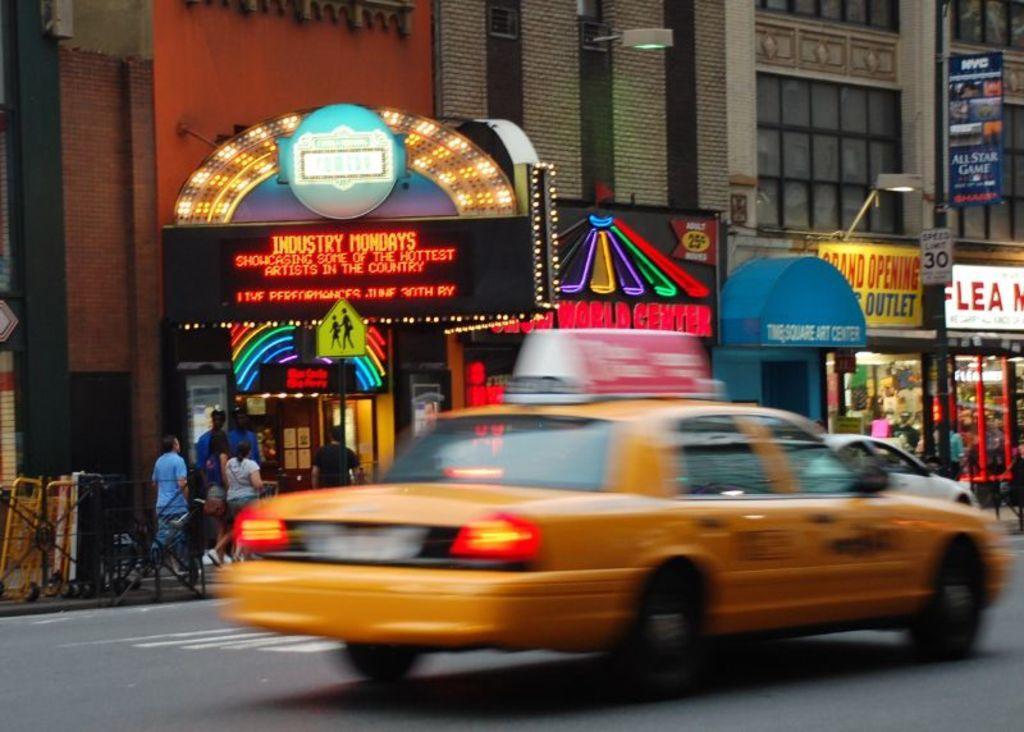How would you summarize this image in a sentence or two? In this picture we can see there are vehicles on the road. Behind the vehicles, there are boards, barricades, buildings and people. There is a pole with a signboard. On the right side of the image, there are some objects inside the building. 